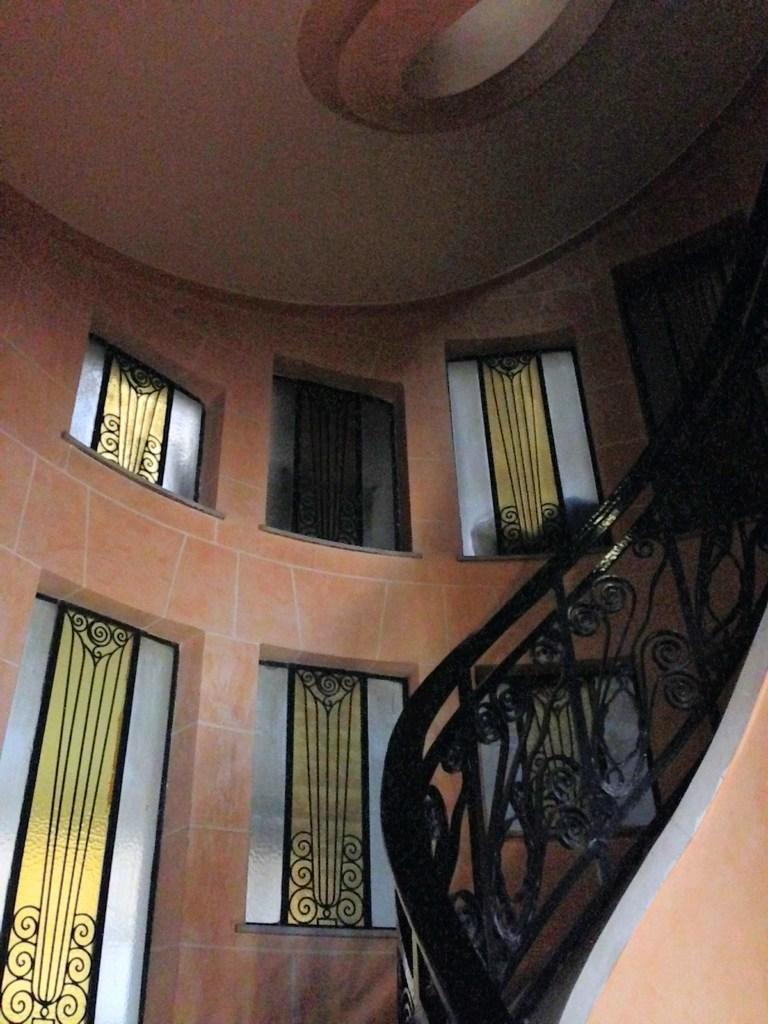What type of architectural feature is present in the image? There is a staircase in the image. What objects can be seen on the staircase? There are design glasses on the staircase. What is the background of the image made of? There is a wall in the image. What is above the wall in the image? There is a ceiling in the image. What type of bun can be seen in the image? There is no bun present in the image. How many toes are visible in the image? There are no toes visible in the image. 